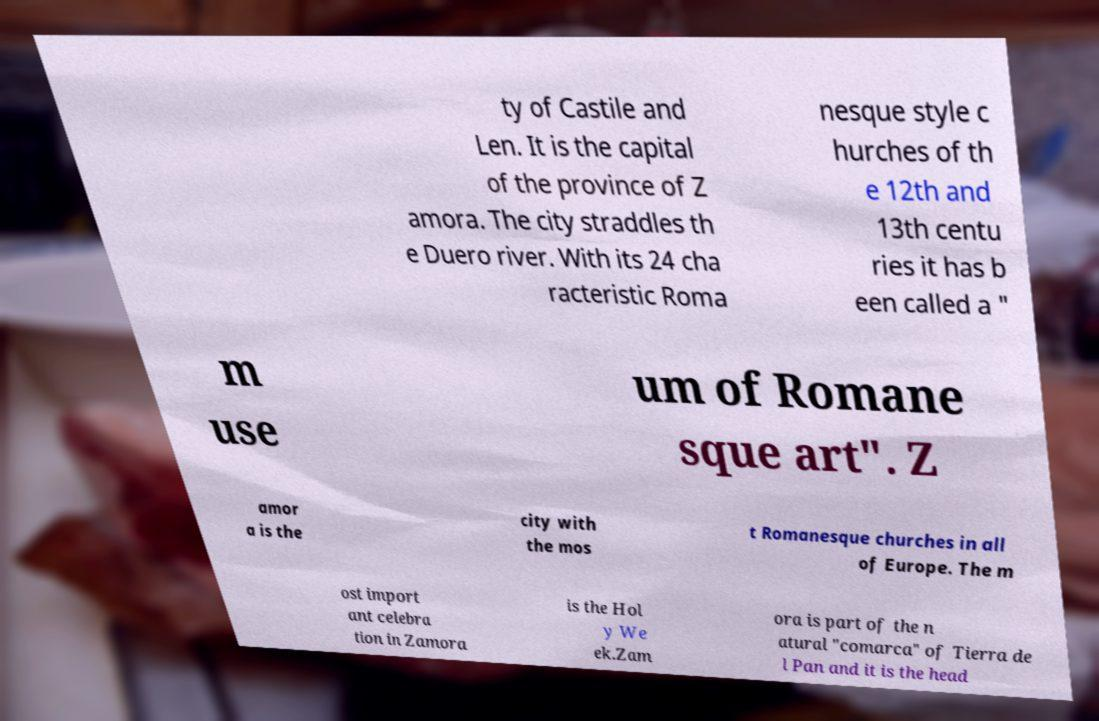Can you read and provide the text displayed in the image?This photo seems to have some interesting text. Can you extract and type it out for me? ty of Castile and Len. It is the capital of the province of Z amora. The city straddles th e Duero river. With its 24 cha racteristic Roma nesque style c hurches of th e 12th and 13th centu ries it has b een called a " m use um of Romane sque art". Z amor a is the city with the mos t Romanesque churches in all of Europe. The m ost import ant celebra tion in Zamora is the Hol y We ek.Zam ora is part of the n atural "comarca" of Tierra de l Pan and it is the head 